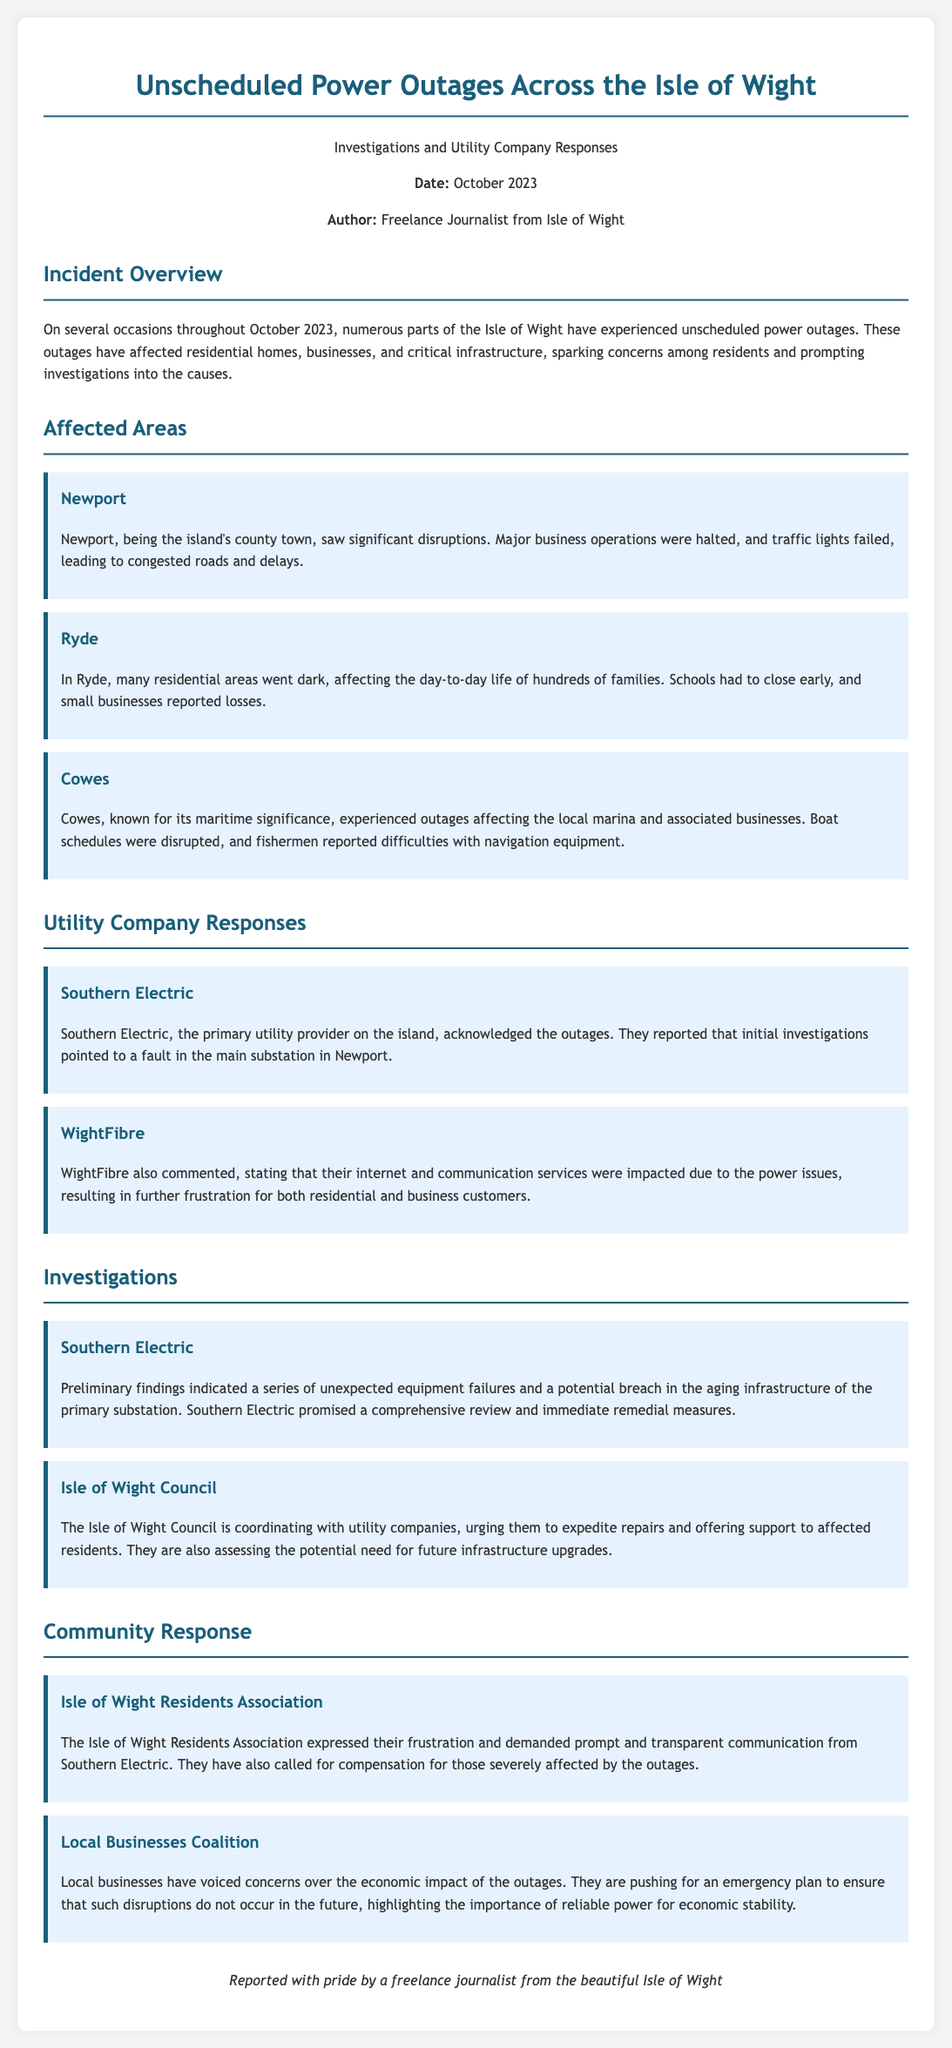What month did the outages occur? The document states that the outages occurred in October 2023.
Answer: October 2023 Which utility company acknowledged the outages? The document mentions Southern Electric as the primary utility provider that acknowledged the outages.
Answer: Southern Electric What major area faced significant disruptions? Newport is specified as experiencing significant disruptions due to the outages.
Answer: Newport What was a reported consequence in Ryde? The document states that schools had to close early in Ryde due to the power outages.
Answer: Schools closed early Who is coordinating with utility companies? The Isle of Wight Council is mentioned as coordinating with utility companies regarding the outages.
Answer: Isle of Wight Council What did the Isle of Wight Residents Association demand? The document states that they demanded prompt and transparent communication from Southern Electric.
Answer: Transparent communication What economic impact did local businesses experience? Local businesses voiced concerns over economic impacts due to power outages.
Answer: Economic impact What caused the outages according to preliminary findings? Initial investigations indicated unexpected equipment failures and breaches in the infrastructure.
Answer: Equipment failures What type of support did the Isle of Wight Council offer? The Isle of Wight Council offered support to affected residents during the outages.
Answer: Support to affected residents 